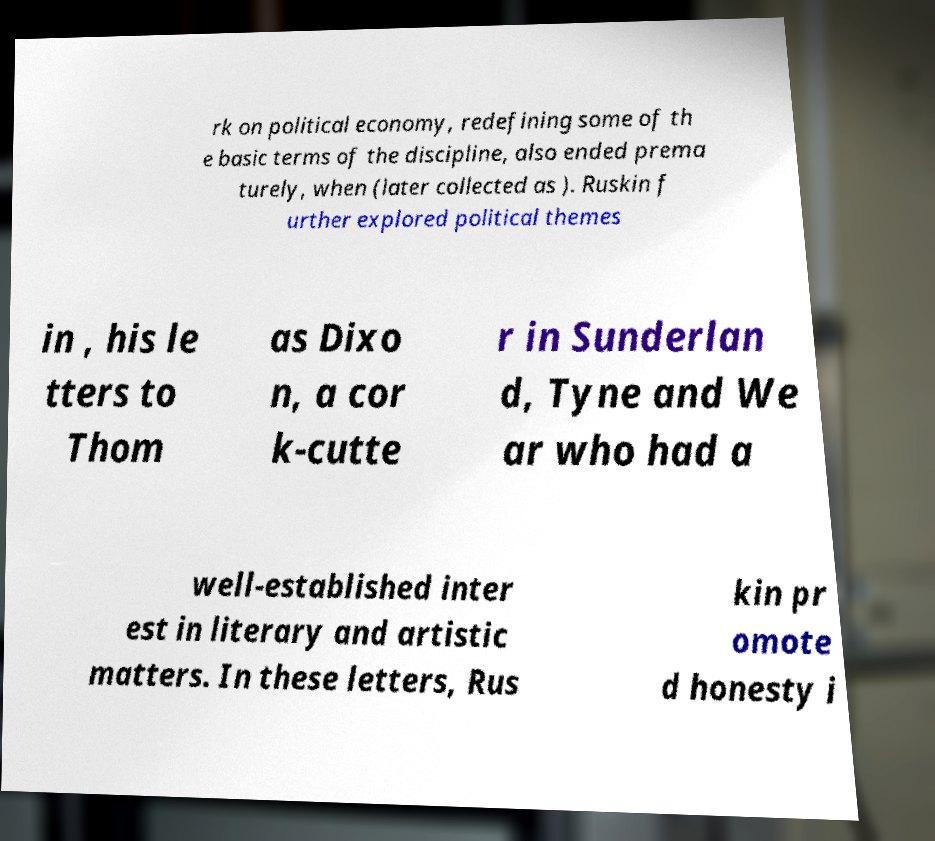There's text embedded in this image that I need extracted. Can you transcribe it verbatim? rk on political economy, redefining some of th e basic terms of the discipline, also ended prema turely, when (later collected as ). Ruskin f urther explored political themes in , his le tters to Thom as Dixo n, a cor k-cutte r in Sunderlan d, Tyne and We ar who had a well-established inter est in literary and artistic matters. In these letters, Rus kin pr omote d honesty i 